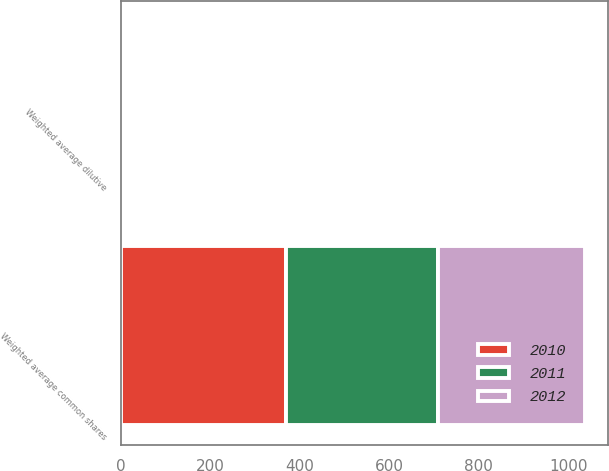Convert chart to OTSL. <chart><loc_0><loc_0><loc_500><loc_500><stacked_bar_chart><ecel><fcel>Weighted average common shares<fcel>Weighted average dilutive<nl><fcel>2012<fcel>328.4<fcel>4.7<nl><fcel>2011<fcel>339.9<fcel>4<nl><fcel>2010<fcel>368.3<fcel>4.1<nl></chart> 